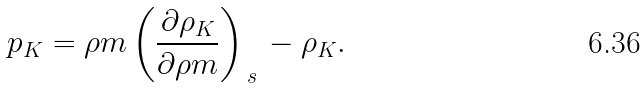<formula> <loc_0><loc_0><loc_500><loc_500>p _ { K } = \rho m \left ( \frac { \partial \rho _ { K } } { \partial \rho m } \right ) _ { \, s \, } - \rho _ { K } .</formula> 